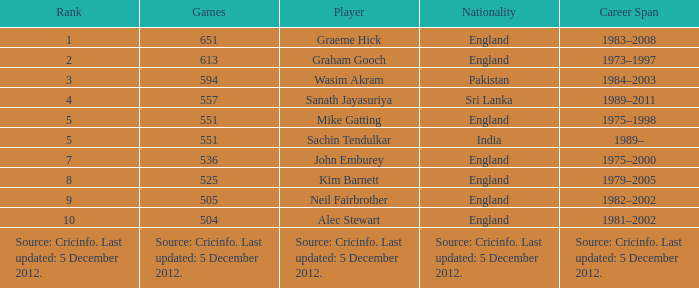What is graham gooch's citizenship? England. 